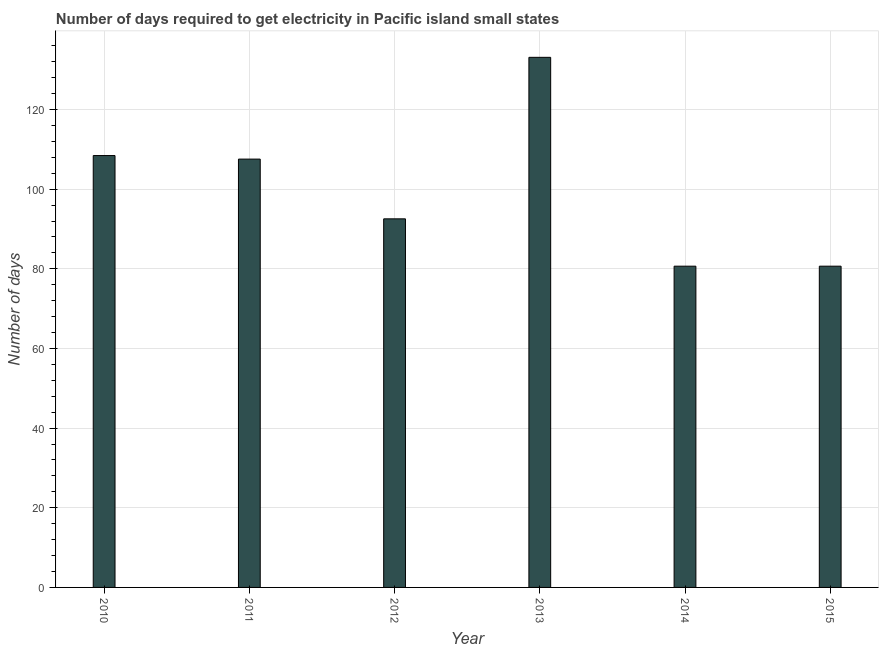Does the graph contain any zero values?
Your response must be concise. No. What is the title of the graph?
Ensure brevity in your answer.  Number of days required to get electricity in Pacific island small states. What is the label or title of the X-axis?
Your answer should be compact. Year. What is the label or title of the Y-axis?
Provide a short and direct response. Number of days. What is the time to get electricity in 2013?
Provide a short and direct response. 133.11. Across all years, what is the maximum time to get electricity?
Give a very brief answer. 133.11. Across all years, what is the minimum time to get electricity?
Provide a succinct answer. 80.67. In which year was the time to get electricity maximum?
Provide a succinct answer. 2013. In which year was the time to get electricity minimum?
Provide a succinct answer. 2014. What is the sum of the time to get electricity?
Your response must be concise. 603. What is the difference between the time to get electricity in 2010 and 2012?
Keep it short and to the point. 15.89. What is the average time to get electricity per year?
Provide a short and direct response. 100.5. What is the median time to get electricity?
Offer a very short reply. 100.06. What is the ratio of the time to get electricity in 2013 to that in 2015?
Offer a terse response. 1.65. Is the time to get electricity in 2010 less than that in 2013?
Provide a succinct answer. Yes. Is the difference between the time to get electricity in 2014 and 2015 greater than the difference between any two years?
Give a very brief answer. No. What is the difference between the highest and the second highest time to get electricity?
Give a very brief answer. 24.67. Is the sum of the time to get electricity in 2010 and 2013 greater than the maximum time to get electricity across all years?
Your answer should be compact. Yes. What is the difference between the highest and the lowest time to get electricity?
Offer a very short reply. 52.44. What is the difference between two consecutive major ticks on the Y-axis?
Keep it short and to the point. 20. Are the values on the major ticks of Y-axis written in scientific E-notation?
Your answer should be very brief. No. What is the Number of days in 2010?
Your answer should be compact. 108.44. What is the Number of days of 2011?
Provide a short and direct response. 107.56. What is the Number of days of 2012?
Provide a short and direct response. 92.56. What is the Number of days of 2013?
Keep it short and to the point. 133.11. What is the Number of days of 2014?
Provide a succinct answer. 80.67. What is the Number of days in 2015?
Your answer should be very brief. 80.67. What is the difference between the Number of days in 2010 and 2011?
Keep it short and to the point. 0.89. What is the difference between the Number of days in 2010 and 2012?
Give a very brief answer. 15.89. What is the difference between the Number of days in 2010 and 2013?
Ensure brevity in your answer.  -24.67. What is the difference between the Number of days in 2010 and 2014?
Your answer should be very brief. 27.78. What is the difference between the Number of days in 2010 and 2015?
Provide a succinct answer. 27.78. What is the difference between the Number of days in 2011 and 2012?
Offer a very short reply. 15. What is the difference between the Number of days in 2011 and 2013?
Offer a terse response. -25.56. What is the difference between the Number of days in 2011 and 2014?
Offer a very short reply. 26.89. What is the difference between the Number of days in 2011 and 2015?
Offer a terse response. 26.89. What is the difference between the Number of days in 2012 and 2013?
Offer a very short reply. -40.56. What is the difference between the Number of days in 2012 and 2014?
Provide a short and direct response. 11.89. What is the difference between the Number of days in 2012 and 2015?
Make the answer very short. 11.89. What is the difference between the Number of days in 2013 and 2014?
Keep it short and to the point. 52.44. What is the difference between the Number of days in 2013 and 2015?
Offer a very short reply. 52.44. What is the ratio of the Number of days in 2010 to that in 2012?
Make the answer very short. 1.17. What is the ratio of the Number of days in 2010 to that in 2013?
Keep it short and to the point. 0.81. What is the ratio of the Number of days in 2010 to that in 2014?
Make the answer very short. 1.34. What is the ratio of the Number of days in 2010 to that in 2015?
Offer a very short reply. 1.34. What is the ratio of the Number of days in 2011 to that in 2012?
Offer a terse response. 1.16. What is the ratio of the Number of days in 2011 to that in 2013?
Provide a succinct answer. 0.81. What is the ratio of the Number of days in 2011 to that in 2014?
Provide a short and direct response. 1.33. What is the ratio of the Number of days in 2011 to that in 2015?
Your answer should be very brief. 1.33. What is the ratio of the Number of days in 2012 to that in 2013?
Your answer should be compact. 0.69. What is the ratio of the Number of days in 2012 to that in 2014?
Offer a very short reply. 1.15. What is the ratio of the Number of days in 2012 to that in 2015?
Offer a very short reply. 1.15. What is the ratio of the Number of days in 2013 to that in 2014?
Make the answer very short. 1.65. What is the ratio of the Number of days in 2013 to that in 2015?
Your answer should be compact. 1.65. What is the ratio of the Number of days in 2014 to that in 2015?
Your answer should be compact. 1. 